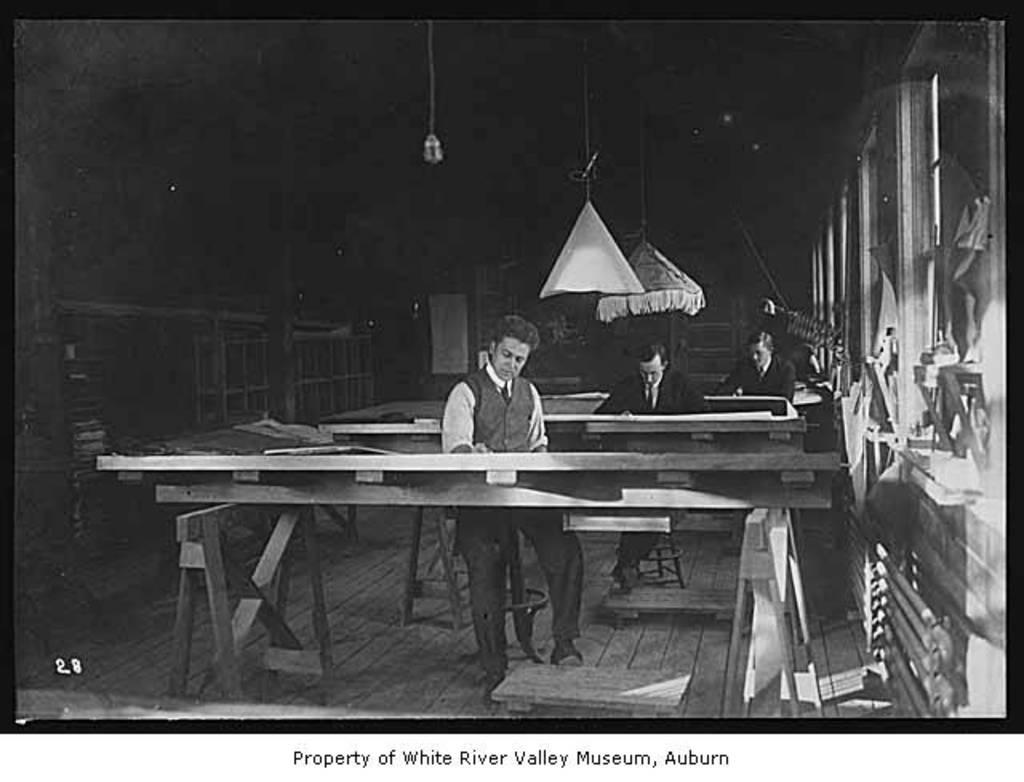How many people are in the image? There are three men in the image. What are the men doing in the image? The men are sitting on chairs and working on a table. What is the color of the background in the image? The background of the image is dark in color. What type of floor is visible in the image? The floor in the image is wooden. What type of trousers are the men wearing in the image? There is no information about the type of trousers the men are wearing in the image. How many cents can be seen on the table in the image? There is no mention of any currency or coins in the image. 